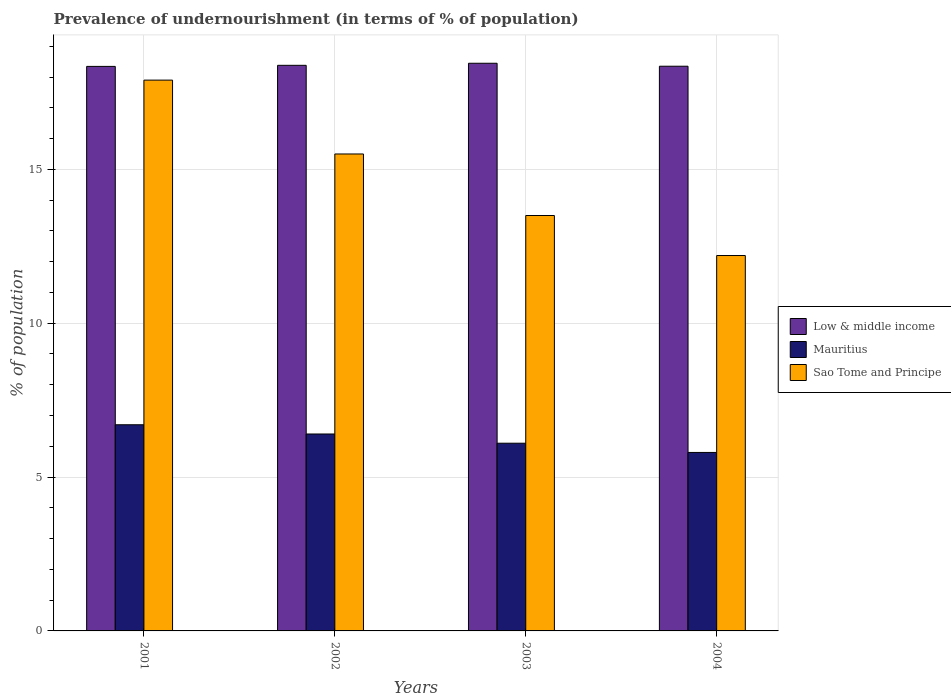How many different coloured bars are there?
Offer a very short reply. 3. Are the number of bars on each tick of the X-axis equal?
Offer a very short reply. Yes. How many bars are there on the 2nd tick from the left?
Your answer should be very brief. 3. In how many cases, is the number of bars for a given year not equal to the number of legend labels?
Ensure brevity in your answer.  0. What is the percentage of undernourished population in Low & middle income in 2004?
Keep it short and to the point. 18.35. Across all years, what is the maximum percentage of undernourished population in Low & middle income?
Your answer should be compact. 18.45. Across all years, what is the minimum percentage of undernourished population in Mauritius?
Keep it short and to the point. 5.8. In which year was the percentage of undernourished population in Sao Tome and Principe minimum?
Your response must be concise. 2004. What is the total percentage of undernourished population in Mauritius in the graph?
Keep it short and to the point. 25. What is the difference between the percentage of undernourished population in Sao Tome and Principe in 2001 and that in 2004?
Ensure brevity in your answer.  5.7. What is the difference between the percentage of undernourished population in Mauritius in 2003 and the percentage of undernourished population in Sao Tome and Principe in 2001?
Offer a very short reply. -11.8. What is the average percentage of undernourished population in Low & middle income per year?
Provide a short and direct response. 18.38. In how many years, is the percentage of undernourished population in Mauritius greater than 1 %?
Offer a very short reply. 4. What is the ratio of the percentage of undernourished population in Low & middle income in 2002 to that in 2004?
Make the answer very short. 1. Is the difference between the percentage of undernourished population in Sao Tome and Principe in 2001 and 2004 greater than the difference between the percentage of undernourished population in Mauritius in 2001 and 2004?
Provide a succinct answer. Yes. What is the difference between the highest and the second highest percentage of undernourished population in Sao Tome and Principe?
Your response must be concise. 2.4. What is the difference between the highest and the lowest percentage of undernourished population in Low & middle income?
Ensure brevity in your answer.  0.1. What does the 2nd bar from the left in 2003 represents?
Offer a very short reply. Mauritius. What does the 2nd bar from the right in 2004 represents?
Provide a short and direct response. Mauritius. Are all the bars in the graph horizontal?
Keep it short and to the point. No. How many years are there in the graph?
Your answer should be compact. 4. What is the difference between two consecutive major ticks on the Y-axis?
Keep it short and to the point. 5. Are the values on the major ticks of Y-axis written in scientific E-notation?
Your answer should be very brief. No. How many legend labels are there?
Keep it short and to the point. 3. What is the title of the graph?
Keep it short and to the point. Prevalence of undernourishment (in terms of % of population). What is the label or title of the Y-axis?
Your response must be concise. % of population. What is the % of population in Low & middle income in 2001?
Your answer should be very brief. 18.35. What is the % of population of Low & middle income in 2002?
Keep it short and to the point. 18.38. What is the % of population in Sao Tome and Principe in 2002?
Offer a very short reply. 15.5. What is the % of population in Low & middle income in 2003?
Your answer should be compact. 18.45. What is the % of population in Mauritius in 2003?
Offer a very short reply. 6.1. What is the % of population of Low & middle income in 2004?
Make the answer very short. 18.35. What is the % of population of Mauritius in 2004?
Provide a short and direct response. 5.8. Across all years, what is the maximum % of population of Low & middle income?
Offer a very short reply. 18.45. Across all years, what is the maximum % of population of Mauritius?
Give a very brief answer. 6.7. Across all years, what is the minimum % of population of Low & middle income?
Offer a very short reply. 18.35. What is the total % of population of Low & middle income in the graph?
Make the answer very short. 73.53. What is the total % of population of Mauritius in the graph?
Keep it short and to the point. 25. What is the total % of population of Sao Tome and Principe in the graph?
Ensure brevity in your answer.  59.1. What is the difference between the % of population of Low & middle income in 2001 and that in 2002?
Your answer should be compact. -0.03. What is the difference between the % of population in Mauritius in 2001 and that in 2002?
Make the answer very short. 0.3. What is the difference between the % of population in Sao Tome and Principe in 2001 and that in 2002?
Provide a short and direct response. 2.4. What is the difference between the % of population in Low & middle income in 2001 and that in 2003?
Give a very brief answer. -0.1. What is the difference between the % of population of Mauritius in 2001 and that in 2003?
Offer a terse response. 0.6. What is the difference between the % of population in Low & middle income in 2001 and that in 2004?
Your answer should be compact. -0.01. What is the difference between the % of population in Mauritius in 2001 and that in 2004?
Ensure brevity in your answer.  0.9. What is the difference between the % of population in Sao Tome and Principe in 2001 and that in 2004?
Offer a very short reply. 5.7. What is the difference between the % of population of Low & middle income in 2002 and that in 2003?
Provide a succinct answer. -0.07. What is the difference between the % of population in Low & middle income in 2002 and that in 2004?
Offer a very short reply. 0.03. What is the difference between the % of population in Mauritius in 2002 and that in 2004?
Keep it short and to the point. 0.6. What is the difference between the % of population in Sao Tome and Principe in 2002 and that in 2004?
Ensure brevity in your answer.  3.3. What is the difference between the % of population of Low & middle income in 2003 and that in 2004?
Offer a very short reply. 0.1. What is the difference between the % of population in Mauritius in 2003 and that in 2004?
Give a very brief answer. 0.3. What is the difference between the % of population of Sao Tome and Principe in 2003 and that in 2004?
Make the answer very short. 1.3. What is the difference between the % of population of Low & middle income in 2001 and the % of population of Mauritius in 2002?
Give a very brief answer. 11.95. What is the difference between the % of population in Low & middle income in 2001 and the % of population in Sao Tome and Principe in 2002?
Provide a succinct answer. 2.85. What is the difference between the % of population in Low & middle income in 2001 and the % of population in Mauritius in 2003?
Provide a short and direct response. 12.25. What is the difference between the % of population in Low & middle income in 2001 and the % of population in Sao Tome and Principe in 2003?
Your response must be concise. 4.85. What is the difference between the % of population of Mauritius in 2001 and the % of population of Sao Tome and Principe in 2003?
Give a very brief answer. -6.8. What is the difference between the % of population in Low & middle income in 2001 and the % of population in Mauritius in 2004?
Your answer should be compact. 12.55. What is the difference between the % of population in Low & middle income in 2001 and the % of population in Sao Tome and Principe in 2004?
Your answer should be very brief. 6.15. What is the difference between the % of population in Mauritius in 2001 and the % of population in Sao Tome and Principe in 2004?
Keep it short and to the point. -5.5. What is the difference between the % of population of Low & middle income in 2002 and the % of population of Mauritius in 2003?
Make the answer very short. 12.28. What is the difference between the % of population of Low & middle income in 2002 and the % of population of Sao Tome and Principe in 2003?
Provide a succinct answer. 4.88. What is the difference between the % of population of Mauritius in 2002 and the % of population of Sao Tome and Principe in 2003?
Your answer should be compact. -7.1. What is the difference between the % of population of Low & middle income in 2002 and the % of population of Mauritius in 2004?
Make the answer very short. 12.58. What is the difference between the % of population of Low & middle income in 2002 and the % of population of Sao Tome and Principe in 2004?
Make the answer very short. 6.18. What is the difference between the % of population of Low & middle income in 2003 and the % of population of Mauritius in 2004?
Your response must be concise. 12.65. What is the difference between the % of population in Low & middle income in 2003 and the % of population in Sao Tome and Principe in 2004?
Your answer should be compact. 6.25. What is the average % of population of Low & middle income per year?
Your response must be concise. 18.38. What is the average % of population of Mauritius per year?
Your response must be concise. 6.25. What is the average % of population of Sao Tome and Principe per year?
Offer a terse response. 14.78. In the year 2001, what is the difference between the % of population of Low & middle income and % of population of Mauritius?
Provide a short and direct response. 11.65. In the year 2001, what is the difference between the % of population of Low & middle income and % of population of Sao Tome and Principe?
Give a very brief answer. 0.45. In the year 2002, what is the difference between the % of population of Low & middle income and % of population of Mauritius?
Your response must be concise. 11.98. In the year 2002, what is the difference between the % of population in Low & middle income and % of population in Sao Tome and Principe?
Ensure brevity in your answer.  2.88. In the year 2003, what is the difference between the % of population in Low & middle income and % of population in Mauritius?
Your answer should be very brief. 12.35. In the year 2003, what is the difference between the % of population in Low & middle income and % of population in Sao Tome and Principe?
Offer a very short reply. 4.95. In the year 2003, what is the difference between the % of population in Mauritius and % of population in Sao Tome and Principe?
Offer a terse response. -7.4. In the year 2004, what is the difference between the % of population in Low & middle income and % of population in Mauritius?
Offer a terse response. 12.55. In the year 2004, what is the difference between the % of population in Low & middle income and % of population in Sao Tome and Principe?
Offer a terse response. 6.15. In the year 2004, what is the difference between the % of population of Mauritius and % of population of Sao Tome and Principe?
Provide a succinct answer. -6.4. What is the ratio of the % of population of Mauritius in 2001 to that in 2002?
Offer a very short reply. 1.05. What is the ratio of the % of population in Sao Tome and Principe in 2001 to that in 2002?
Keep it short and to the point. 1.15. What is the ratio of the % of population in Mauritius in 2001 to that in 2003?
Keep it short and to the point. 1.1. What is the ratio of the % of population of Sao Tome and Principe in 2001 to that in 2003?
Provide a succinct answer. 1.33. What is the ratio of the % of population of Mauritius in 2001 to that in 2004?
Your response must be concise. 1.16. What is the ratio of the % of population of Sao Tome and Principe in 2001 to that in 2004?
Provide a succinct answer. 1.47. What is the ratio of the % of population of Mauritius in 2002 to that in 2003?
Provide a succinct answer. 1.05. What is the ratio of the % of population in Sao Tome and Principe in 2002 to that in 2003?
Give a very brief answer. 1.15. What is the ratio of the % of population of Low & middle income in 2002 to that in 2004?
Provide a succinct answer. 1. What is the ratio of the % of population in Mauritius in 2002 to that in 2004?
Your answer should be very brief. 1.1. What is the ratio of the % of population of Sao Tome and Principe in 2002 to that in 2004?
Ensure brevity in your answer.  1.27. What is the ratio of the % of population of Mauritius in 2003 to that in 2004?
Ensure brevity in your answer.  1.05. What is the ratio of the % of population of Sao Tome and Principe in 2003 to that in 2004?
Ensure brevity in your answer.  1.11. What is the difference between the highest and the second highest % of population of Low & middle income?
Provide a short and direct response. 0.07. What is the difference between the highest and the lowest % of population in Low & middle income?
Make the answer very short. 0.1. 